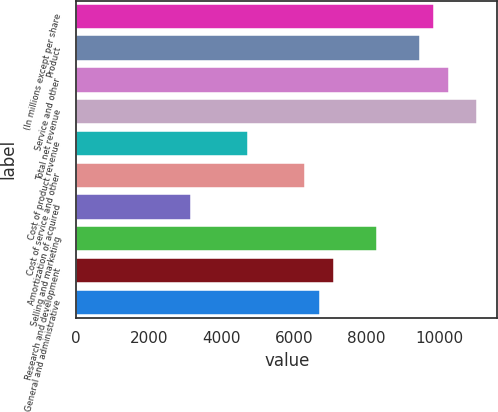Convert chart. <chart><loc_0><loc_0><loc_500><loc_500><bar_chart><fcel>(In millions except per share<fcel>Product<fcel>Service and other<fcel>Total net revenue<fcel>Cost of product revenue<fcel>Cost of service and other<fcel>Amortization of acquired<fcel>Selling and marketing<fcel>Research and development<fcel>General and administrative<nl><fcel>9864.67<fcel>9470.09<fcel>10259.2<fcel>11048.4<fcel>4735.13<fcel>6313.45<fcel>3156.81<fcel>8286.35<fcel>7102.61<fcel>6708.03<nl></chart> 